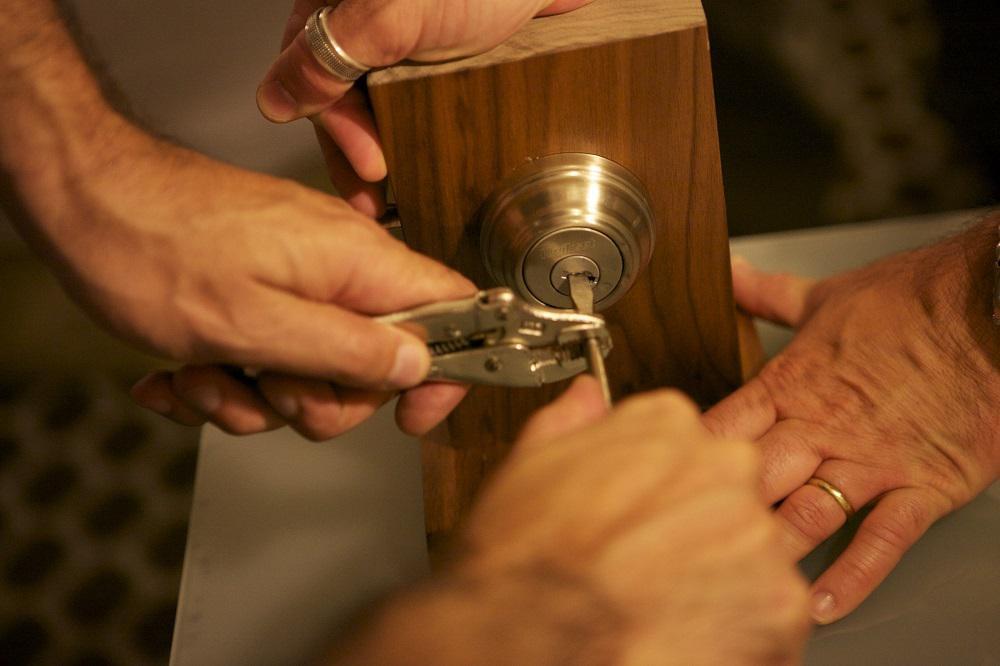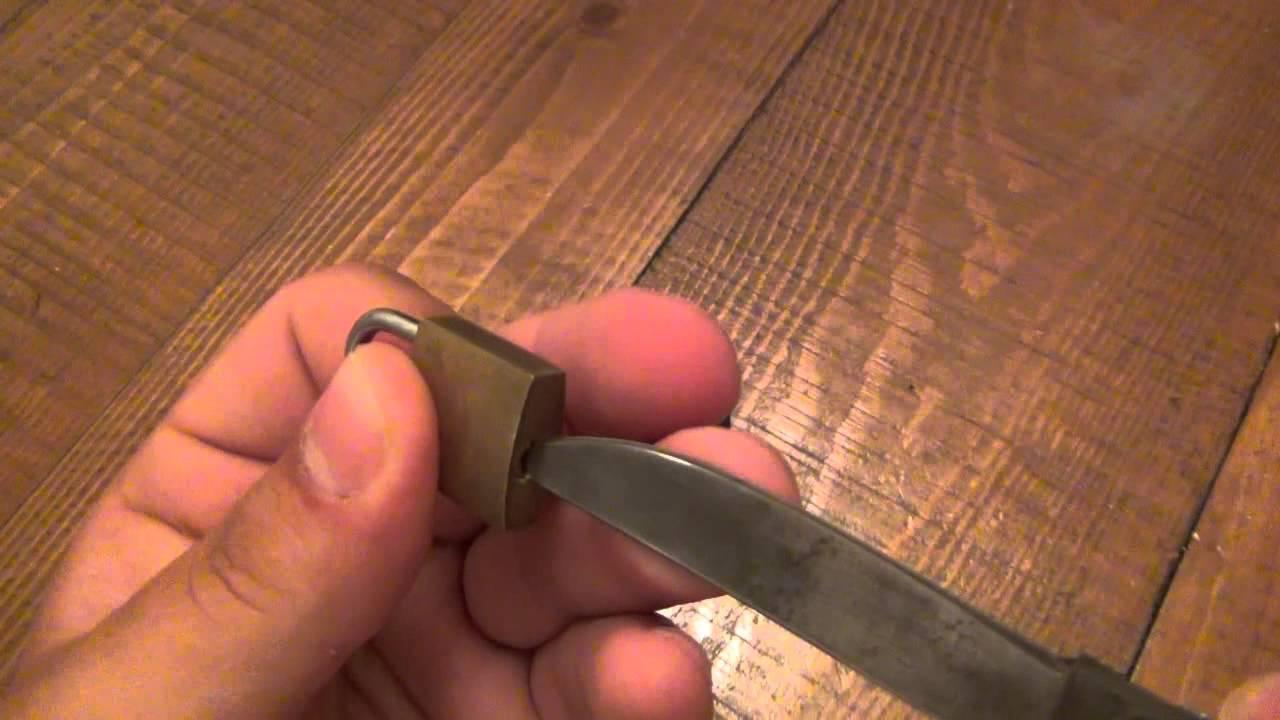The first image is the image on the left, the second image is the image on the right. Evaluate the accuracy of this statement regarding the images: "The right image shows a hand inserting something pointed into the keyhole.". Is it true? Answer yes or no. Yes. 